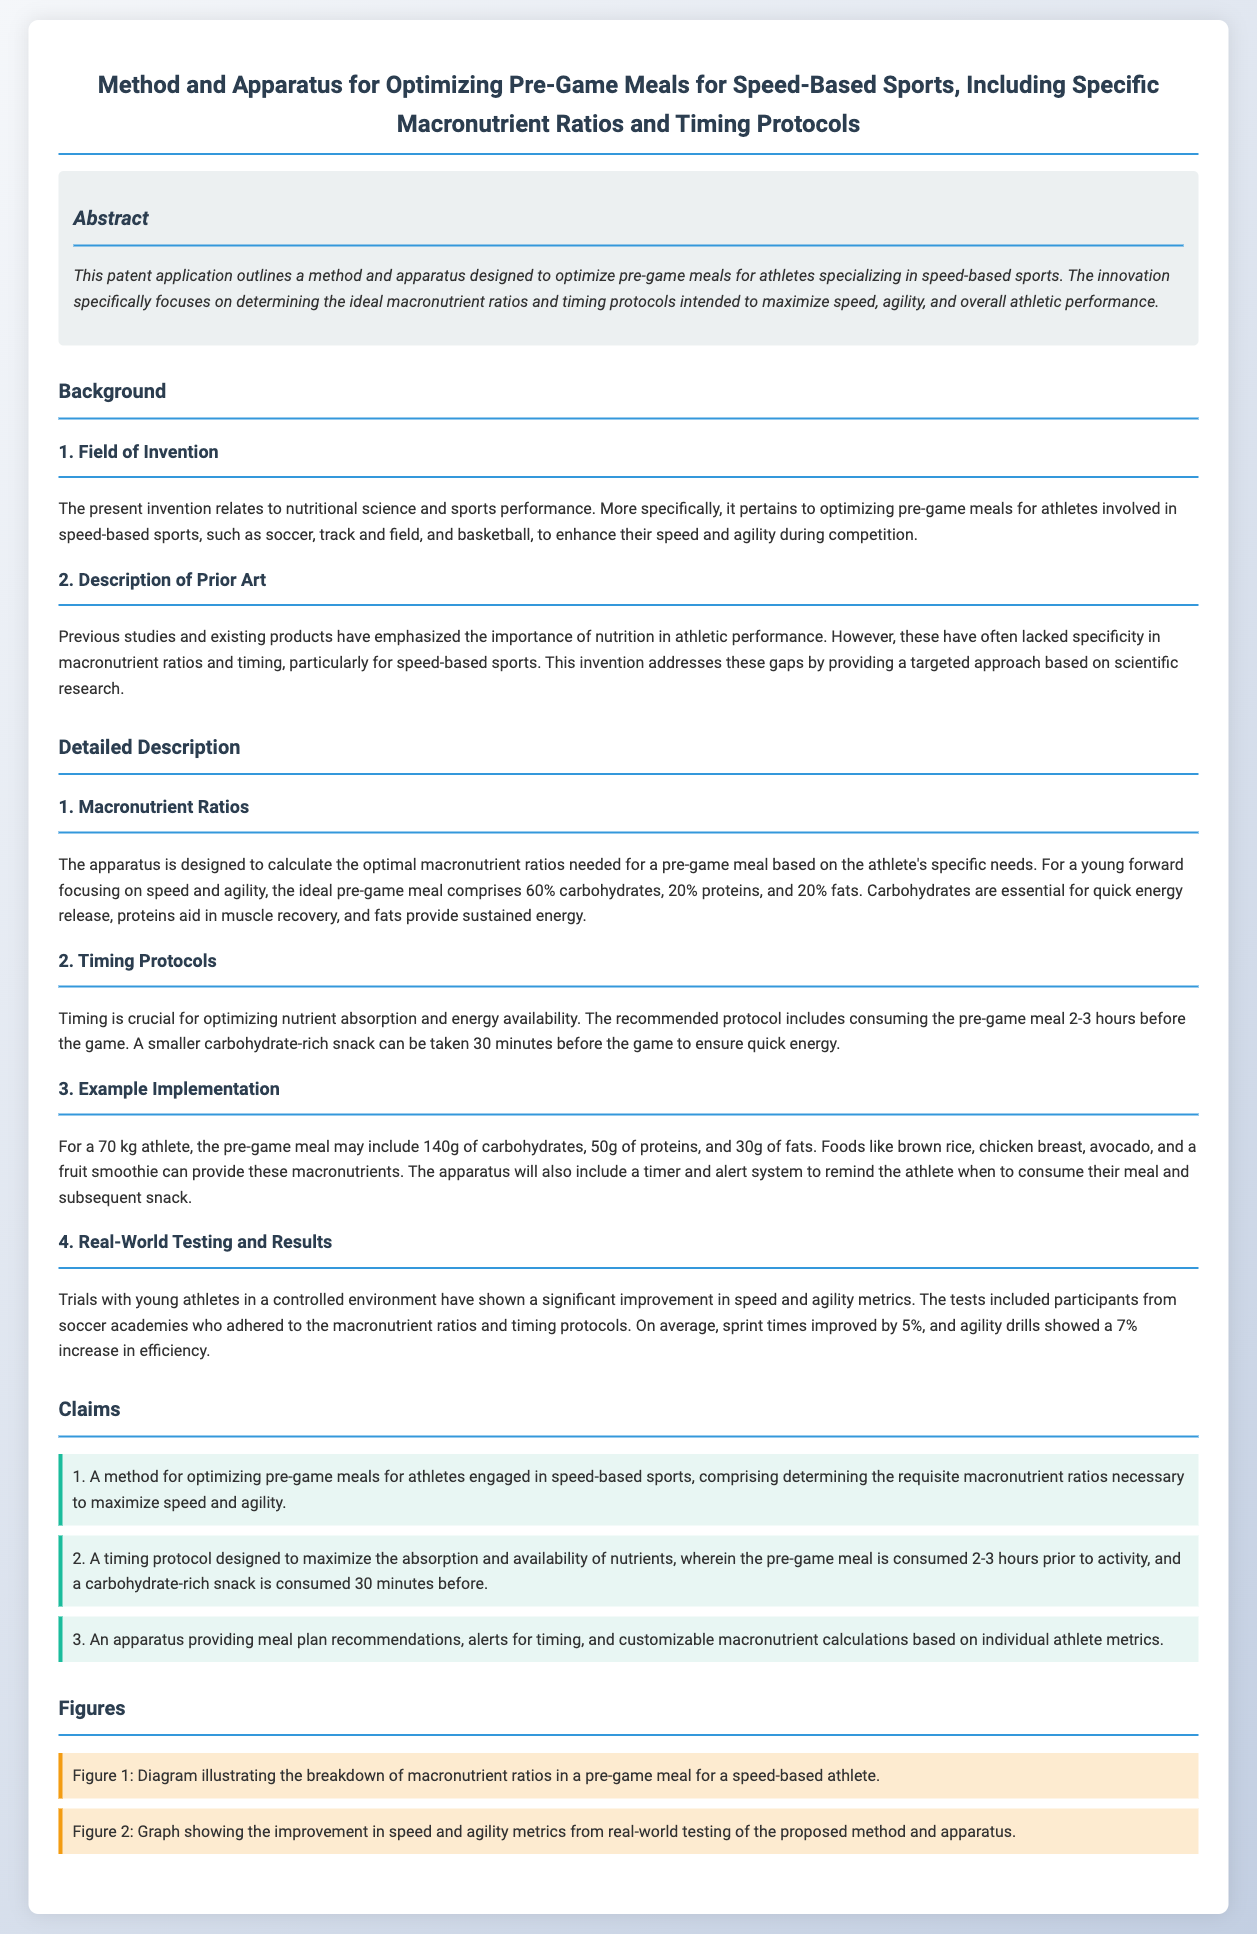What is the main focus of the patent? The patent focuses on optimizing pre-game meals for athletes in speed-based sports, specifically macronutrient ratios and timing.
Answer: optimizing pre-game meals What are the ideal macronutrient ratios for a young forward? The ideal macronutrient ratios for a young forward focusing on speed and agility are provided in the document.
Answer: 60% carbohydrates, 20% proteins, 20% fats How long before a game should the pre-game meal be consumed? The recommended timing for consuming the pre-game meal as specified in the document is essential for nutrient availability.
Answer: 2-3 hours What is the carbohydrate amount suggested for a 70 kg athlete's pre-game meal? The document specifies a precise amount for carbohydrates that should be consumed by a 70 kg athlete.
Answer: 140g What improvement percentage in sprint times was observed during trials? The trials conducted with young athletes reported a specific increase in sprint performance metrics.
Answer: 5% What type of snack is recommended 30 minutes before the game? The document specifies the type of snack that should be consumed shortly before the game for optimal energy.
Answer: carbohydrate-rich snack What is the purpose of the apparatus mentioned in the claims? The claims detail the function of the apparatus in relation to meal planning and athlete support.
Answer: meal plan recommendations Which field does this invention relate to? The background section states the field associated with the invention, highlighting its focus.
Answer: nutritional science and sports performance What percentage increase was noted in agility drills? The overall findings of the tests focused on speed and agility metrics as written in the real-world testing results.
Answer: 7% 